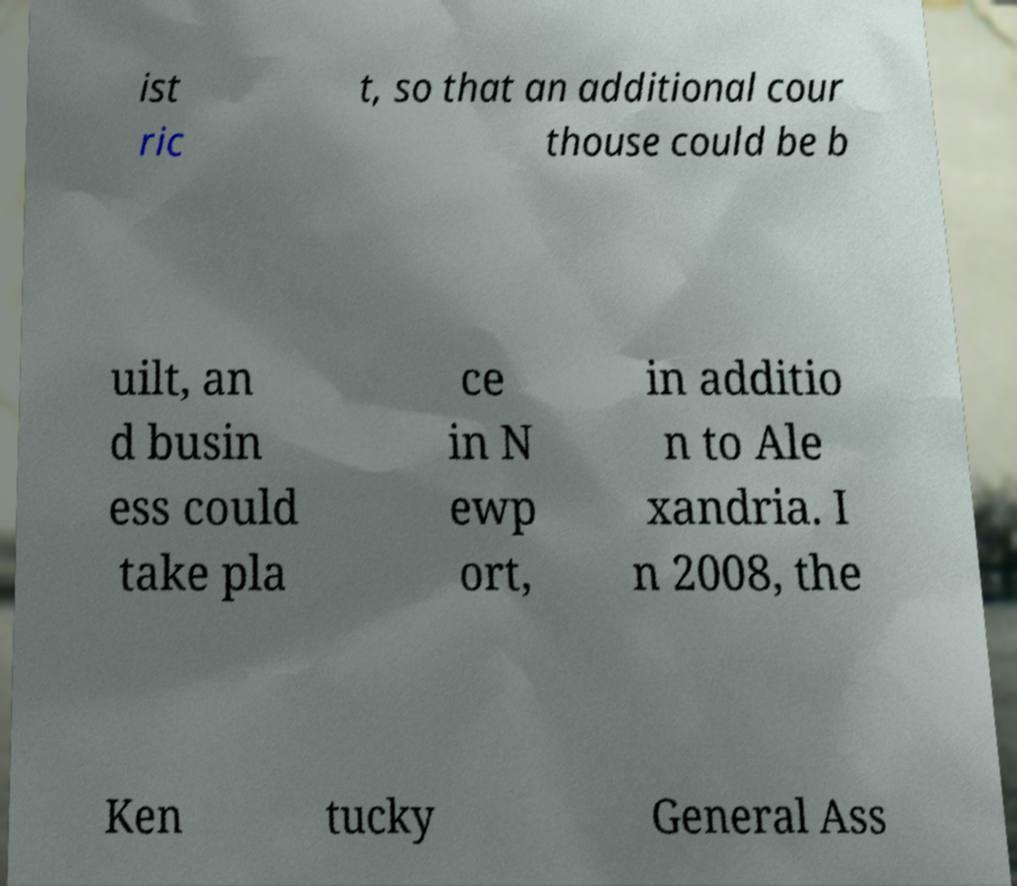Please read and relay the text visible in this image. What does it say? ist ric t, so that an additional cour thouse could be b uilt, an d busin ess could take pla ce in N ewp ort, in additio n to Ale xandria. I n 2008, the Ken tucky General Ass 